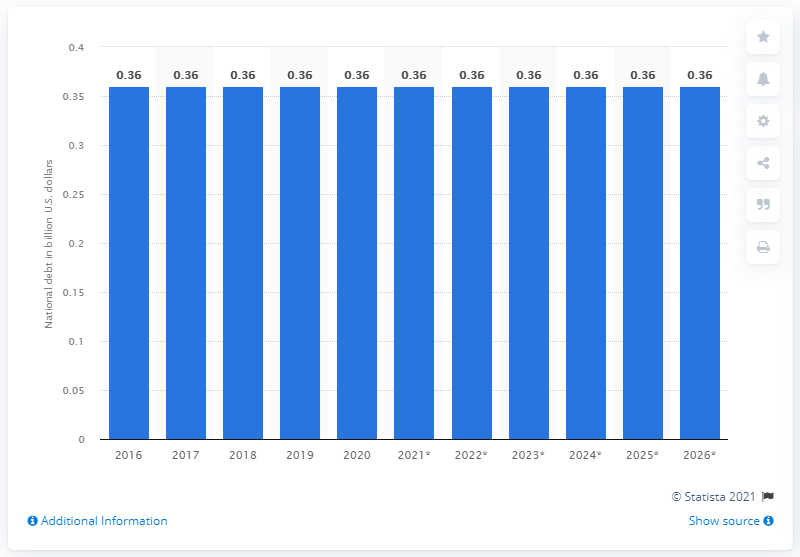List a handful of essential elements in this visual. The national debt of Brunei Darussalam in 2020 was approximately 0.36 billion dollars. 